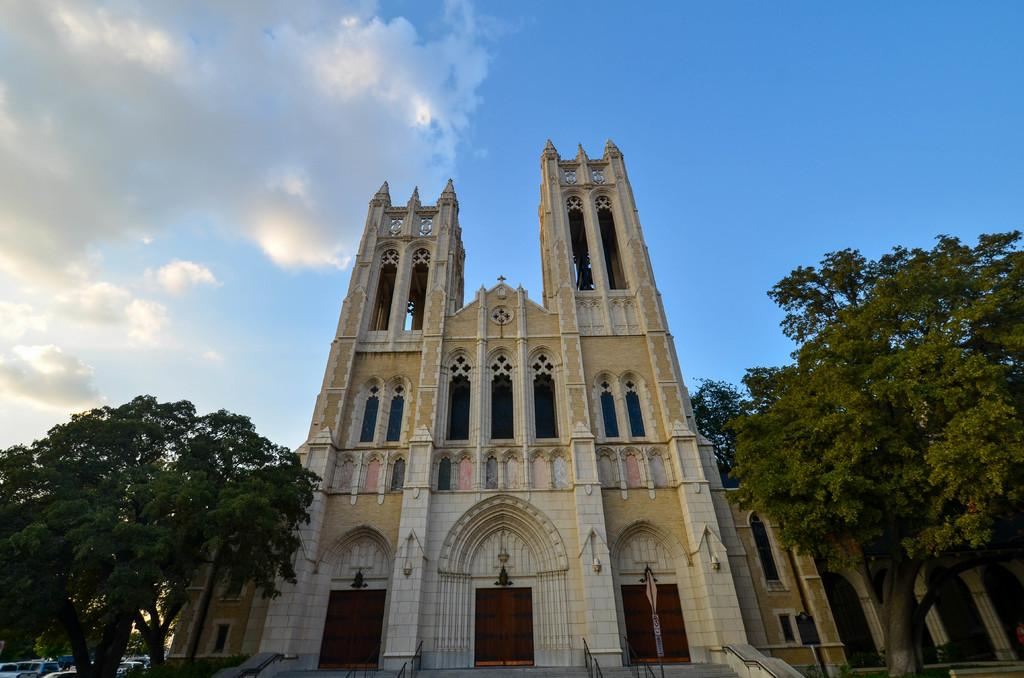What can be seen at the bottom of the image? There are trees, buildings, vehicles, and poles at the bottom of the image. What is visible at the top of the image? There are clouds and sky visible at the top of the image. How does the sea affect the buildings at the bottom of the image? There is no sea present in the image; it features trees, buildings, vehicles, and poles at the bottom. What achievements has the achiever accomplished in the image? There is no achiever or any indication of achievements in the image. 